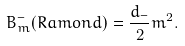<formula> <loc_0><loc_0><loc_500><loc_500>B _ { m } ^ { - } ( R a m o n d ) = \frac { d _ { - } } { 2 } m ^ { 2 } .</formula> 